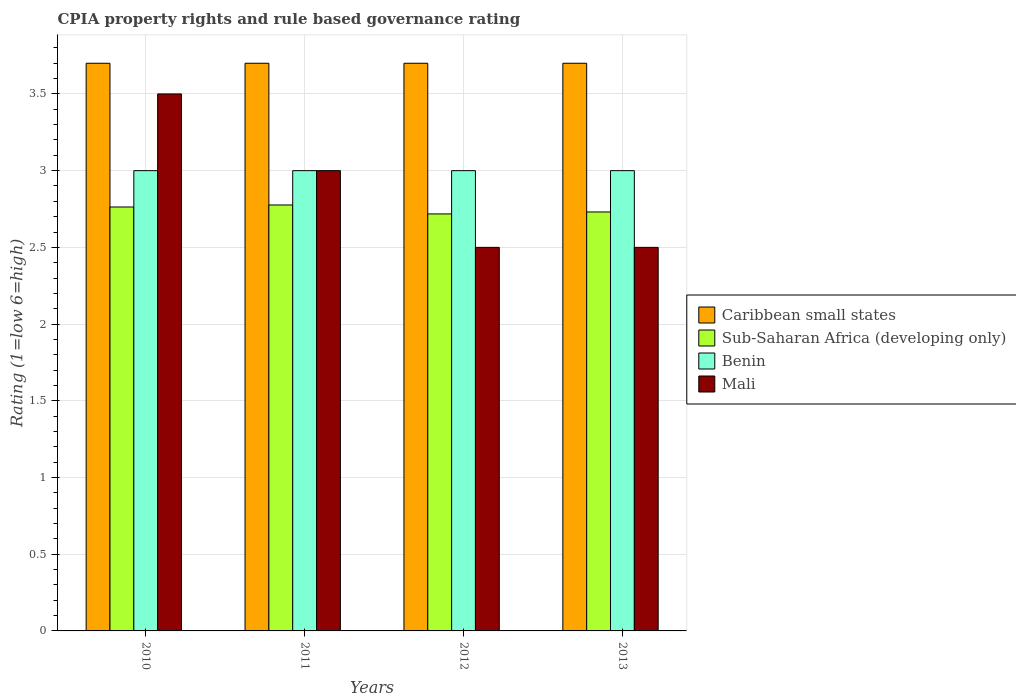How many different coloured bars are there?
Your response must be concise. 4. How many groups of bars are there?
Ensure brevity in your answer.  4. Are the number of bars per tick equal to the number of legend labels?
Your response must be concise. Yes. Are the number of bars on each tick of the X-axis equal?
Your answer should be very brief. Yes. What is the label of the 2nd group of bars from the left?
Make the answer very short. 2011. In how many cases, is the number of bars for a given year not equal to the number of legend labels?
Keep it short and to the point. 0. What is the CPIA rating in Sub-Saharan Africa (developing only) in 2012?
Provide a short and direct response. 2.72. Across all years, what is the maximum CPIA rating in Mali?
Offer a very short reply. 3.5. In which year was the CPIA rating in Mali maximum?
Offer a very short reply. 2010. In which year was the CPIA rating in Mali minimum?
Ensure brevity in your answer.  2012. What is the total CPIA rating in Mali in the graph?
Provide a succinct answer. 11.5. What is the difference between the CPIA rating in Caribbean small states in 2012 and the CPIA rating in Mali in 2013?
Your answer should be very brief. 1.2. In the year 2010, what is the difference between the CPIA rating in Mali and CPIA rating in Sub-Saharan Africa (developing only)?
Provide a short and direct response. 0.74. In how many years, is the CPIA rating in Caribbean small states greater than 2.4?
Provide a succinct answer. 4. Is the difference between the CPIA rating in Mali in 2012 and 2013 greater than the difference between the CPIA rating in Sub-Saharan Africa (developing only) in 2012 and 2013?
Your answer should be compact. Yes. What is the difference between the highest and the second highest CPIA rating in Caribbean small states?
Your answer should be compact. 0. In how many years, is the CPIA rating in Benin greater than the average CPIA rating in Benin taken over all years?
Provide a short and direct response. 0. Is the sum of the CPIA rating in Sub-Saharan Africa (developing only) in 2011 and 2013 greater than the maximum CPIA rating in Mali across all years?
Give a very brief answer. Yes. Is it the case that in every year, the sum of the CPIA rating in Benin and CPIA rating in Caribbean small states is greater than the sum of CPIA rating in Mali and CPIA rating in Sub-Saharan Africa (developing only)?
Your answer should be compact. Yes. What does the 4th bar from the left in 2010 represents?
Your answer should be compact. Mali. What does the 1st bar from the right in 2010 represents?
Your answer should be compact. Mali. Is it the case that in every year, the sum of the CPIA rating in Benin and CPIA rating in Sub-Saharan Africa (developing only) is greater than the CPIA rating in Caribbean small states?
Offer a very short reply. Yes. How many bars are there?
Your answer should be very brief. 16. Does the graph contain any zero values?
Your answer should be very brief. No. Does the graph contain grids?
Make the answer very short. Yes. What is the title of the graph?
Offer a very short reply. CPIA property rights and rule based governance rating. Does "Other small states" appear as one of the legend labels in the graph?
Offer a terse response. No. What is the label or title of the X-axis?
Ensure brevity in your answer.  Years. What is the Rating (1=low 6=high) of Sub-Saharan Africa (developing only) in 2010?
Offer a terse response. 2.76. What is the Rating (1=low 6=high) of Benin in 2010?
Provide a short and direct response. 3. What is the Rating (1=low 6=high) in Caribbean small states in 2011?
Keep it short and to the point. 3.7. What is the Rating (1=low 6=high) of Sub-Saharan Africa (developing only) in 2011?
Provide a succinct answer. 2.78. What is the Rating (1=low 6=high) of Benin in 2011?
Your answer should be very brief. 3. What is the Rating (1=low 6=high) of Sub-Saharan Africa (developing only) in 2012?
Provide a succinct answer. 2.72. What is the Rating (1=low 6=high) in Benin in 2012?
Provide a succinct answer. 3. What is the Rating (1=low 6=high) in Caribbean small states in 2013?
Give a very brief answer. 3.7. What is the Rating (1=low 6=high) of Sub-Saharan Africa (developing only) in 2013?
Give a very brief answer. 2.73. What is the Rating (1=low 6=high) in Mali in 2013?
Provide a short and direct response. 2.5. Across all years, what is the maximum Rating (1=low 6=high) in Sub-Saharan Africa (developing only)?
Your answer should be very brief. 2.78. Across all years, what is the maximum Rating (1=low 6=high) in Mali?
Give a very brief answer. 3.5. Across all years, what is the minimum Rating (1=low 6=high) of Caribbean small states?
Provide a succinct answer. 3.7. Across all years, what is the minimum Rating (1=low 6=high) in Sub-Saharan Africa (developing only)?
Offer a very short reply. 2.72. What is the total Rating (1=low 6=high) of Caribbean small states in the graph?
Your answer should be compact. 14.8. What is the total Rating (1=low 6=high) in Sub-Saharan Africa (developing only) in the graph?
Provide a short and direct response. 10.99. What is the total Rating (1=low 6=high) of Benin in the graph?
Make the answer very short. 12. What is the total Rating (1=low 6=high) in Mali in the graph?
Keep it short and to the point. 11.5. What is the difference between the Rating (1=low 6=high) of Sub-Saharan Africa (developing only) in 2010 and that in 2011?
Provide a succinct answer. -0.01. What is the difference between the Rating (1=low 6=high) of Benin in 2010 and that in 2011?
Your response must be concise. 0. What is the difference between the Rating (1=low 6=high) of Caribbean small states in 2010 and that in 2012?
Offer a very short reply. 0. What is the difference between the Rating (1=low 6=high) of Sub-Saharan Africa (developing only) in 2010 and that in 2012?
Your answer should be compact. 0.05. What is the difference between the Rating (1=low 6=high) in Benin in 2010 and that in 2012?
Provide a succinct answer. 0. What is the difference between the Rating (1=low 6=high) in Mali in 2010 and that in 2012?
Provide a short and direct response. 1. What is the difference between the Rating (1=low 6=high) in Sub-Saharan Africa (developing only) in 2010 and that in 2013?
Your answer should be very brief. 0.03. What is the difference between the Rating (1=low 6=high) of Mali in 2010 and that in 2013?
Keep it short and to the point. 1. What is the difference between the Rating (1=low 6=high) of Sub-Saharan Africa (developing only) in 2011 and that in 2012?
Make the answer very short. 0.06. What is the difference between the Rating (1=low 6=high) in Benin in 2011 and that in 2012?
Your answer should be compact. 0. What is the difference between the Rating (1=low 6=high) in Mali in 2011 and that in 2012?
Ensure brevity in your answer.  0.5. What is the difference between the Rating (1=low 6=high) in Sub-Saharan Africa (developing only) in 2011 and that in 2013?
Provide a short and direct response. 0.05. What is the difference between the Rating (1=low 6=high) of Mali in 2011 and that in 2013?
Ensure brevity in your answer.  0.5. What is the difference between the Rating (1=low 6=high) of Sub-Saharan Africa (developing only) in 2012 and that in 2013?
Your response must be concise. -0.01. What is the difference between the Rating (1=low 6=high) in Caribbean small states in 2010 and the Rating (1=low 6=high) in Sub-Saharan Africa (developing only) in 2011?
Offer a terse response. 0.92. What is the difference between the Rating (1=low 6=high) in Caribbean small states in 2010 and the Rating (1=low 6=high) in Mali in 2011?
Provide a short and direct response. 0.7. What is the difference between the Rating (1=low 6=high) in Sub-Saharan Africa (developing only) in 2010 and the Rating (1=low 6=high) in Benin in 2011?
Keep it short and to the point. -0.24. What is the difference between the Rating (1=low 6=high) of Sub-Saharan Africa (developing only) in 2010 and the Rating (1=low 6=high) of Mali in 2011?
Offer a terse response. -0.24. What is the difference between the Rating (1=low 6=high) of Benin in 2010 and the Rating (1=low 6=high) of Mali in 2011?
Make the answer very short. 0. What is the difference between the Rating (1=low 6=high) in Caribbean small states in 2010 and the Rating (1=low 6=high) in Sub-Saharan Africa (developing only) in 2012?
Give a very brief answer. 0.98. What is the difference between the Rating (1=low 6=high) in Caribbean small states in 2010 and the Rating (1=low 6=high) in Benin in 2012?
Keep it short and to the point. 0.7. What is the difference between the Rating (1=low 6=high) in Caribbean small states in 2010 and the Rating (1=low 6=high) in Mali in 2012?
Provide a succinct answer. 1.2. What is the difference between the Rating (1=low 6=high) in Sub-Saharan Africa (developing only) in 2010 and the Rating (1=low 6=high) in Benin in 2012?
Provide a short and direct response. -0.24. What is the difference between the Rating (1=low 6=high) of Sub-Saharan Africa (developing only) in 2010 and the Rating (1=low 6=high) of Mali in 2012?
Make the answer very short. 0.26. What is the difference between the Rating (1=low 6=high) in Caribbean small states in 2010 and the Rating (1=low 6=high) in Sub-Saharan Africa (developing only) in 2013?
Make the answer very short. 0.97. What is the difference between the Rating (1=low 6=high) of Caribbean small states in 2010 and the Rating (1=low 6=high) of Benin in 2013?
Keep it short and to the point. 0.7. What is the difference between the Rating (1=low 6=high) of Sub-Saharan Africa (developing only) in 2010 and the Rating (1=low 6=high) of Benin in 2013?
Provide a succinct answer. -0.24. What is the difference between the Rating (1=low 6=high) of Sub-Saharan Africa (developing only) in 2010 and the Rating (1=low 6=high) of Mali in 2013?
Your answer should be very brief. 0.26. What is the difference between the Rating (1=low 6=high) of Benin in 2010 and the Rating (1=low 6=high) of Mali in 2013?
Give a very brief answer. 0.5. What is the difference between the Rating (1=low 6=high) in Caribbean small states in 2011 and the Rating (1=low 6=high) in Sub-Saharan Africa (developing only) in 2012?
Ensure brevity in your answer.  0.98. What is the difference between the Rating (1=low 6=high) of Caribbean small states in 2011 and the Rating (1=low 6=high) of Benin in 2012?
Provide a short and direct response. 0.7. What is the difference between the Rating (1=low 6=high) of Caribbean small states in 2011 and the Rating (1=low 6=high) of Mali in 2012?
Your answer should be compact. 1.2. What is the difference between the Rating (1=low 6=high) in Sub-Saharan Africa (developing only) in 2011 and the Rating (1=low 6=high) in Benin in 2012?
Give a very brief answer. -0.22. What is the difference between the Rating (1=low 6=high) of Sub-Saharan Africa (developing only) in 2011 and the Rating (1=low 6=high) of Mali in 2012?
Give a very brief answer. 0.28. What is the difference between the Rating (1=low 6=high) in Caribbean small states in 2011 and the Rating (1=low 6=high) in Sub-Saharan Africa (developing only) in 2013?
Keep it short and to the point. 0.97. What is the difference between the Rating (1=low 6=high) in Sub-Saharan Africa (developing only) in 2011 and the Rating (1=low 6=high) in Benin in 2013?
Keep it short and to the point. -0.22. What is the difference between the Rating (1=low 6=high) of Sub-Saharan Africa (developing only) in 2011 and the Rating (1=low 6=high) of Mali in 2013?
Provide a succinct answer. 0.28. What is the difference between the Rating (1=low 6=high) of Caribbean small states in 2012 and the Rating (1=low 6=high) of Sub-Saharan Africa (developing only) in 2013?
Your answer should be compact. 0.97. What is the difference between the Rating (1=low 6=high) of Sub-Saharan Africa (developing only) in 2012 and the Rating (1=low 6=high) of Benin in 2013?
Provide a short and direct response. -0.28. What is the difference between the Rating (1=low 6=high) in Sub-Saharan Africa (developing only) in 2012 and the Rating (1=low 6=high) in Mali in 2013?
Provide a short and direct response. 0.22. What is the difference between the Rating (1=low 6=high) of Benin in 2012 and the Rating (1=low 6=high) of Mali in 2013?
Make the answer very short. 0.5. What is the average Rating (1=low 6=high) in Caribbean small states per year?
Provide a succinct answer. 3.7. What is the average Rating (1=low 6=high) of Sub-Saharan Africa (developing only) per year?
Make the answer very short. 2.75. What is the average Rating (1=low 6=high) in Benin per year?
Your response must be concise. 3. What is the average Rating (1=low 6=high) of Mali per year?
Give a very brief answer. 2.88. In the year 2010, what is the difference between the Rating (1=low 6=high) of Caribbean small states and Rating (1=low 6=high) of Sub-Saharan Africa (developing only)?
Ensure brevity in your answer.  0.94. In the year 2010, what is the difference between the Rating (1=low 6=high) in Caribbean small states and Rating (1=low 6=high) in Benin?
Offer a terse response. 0.7. In the year 2010, what is the difference between the Rating (1=low 6=high) in Sub-Saharan Africa (developing only) and Rating (1=low 6=high) in Benin?
Ensure brevity in your answer.  -0.24. In the year 2010, what is the difference between the Rating (1=low 6=high) of Sub-Saharan Africa (developing only) and Rating (1=low 6=high) of Mali?
Offer a terse response. -0.74. In the year 2011, what is the difference between the Rating (1=low 6=high) in Caribbean small states and Rating (1=low 6=high) in Sub-Saharan Africa (developing only)?
Your answer should be very brief. 0.92. In the year 2011, what is the difference between the Rating (1=low 6=high) in Caribbean small states and Rating (1=low 6=high) in Mali?
Provide a succinct answer. 0.7. In the year 2011, what is the difference between the Rating (1=low 6=high) of Sub-Saharan Africa (developing only) and Rating (1=low 6=high) of Benin?
Your response must be concise. -0.22. In the year 2011, what is the difference between the Rating (1=low 6=high) in Sub-Saharan Africa (developing only) and Rating (1=low 6=high) in Mali?
Offer a very short reply. -0.22. In the year 2012, what is the difference between the Rating (1=low 6=high) in Caribbean small states and Rating (1=low 6=high) in Sub-Saharan Africa (developing only)?
Offer a very short reply. 0.98. In the year 2012, what is the difference between the Rating (1=low 6=high) of Sub-Saharan Africa (developing only) and Rating (1=low 6=high) of Benin?
Your answer should be very brief. -0.28. In the year 2012, what is the difference between the Rating (1=low 6=high) of Sub-Saharan Africa (developing only) and Rating (1=low 6=high) of Mali?
Your answer should be compact. 0.22. In the year 2012, what is the difference between the Rating (1=low 6=high) in Benin and Rating (1=low 6=high) in Mali?
Give a very brief answer. 0.5. In the year 2013, what is the difference between the Rating (1=low 6=high) of Caribbean small states and Rating (1=low 6=high) of Sub-Saharan Africa (developing only)?
Your answer should be compact. 0.97. In the year 2013, what is the difference between the Rating (1=low 6=high) in Sub-Saharan Africa (developing only) and Rating (1=low 6=high) in Benin?
Your answer should be very brief. -0.27. In the year 2013, what is the difference between the Rating (1=low 6=high) in Sub-Saharan Africa (developing only) and Rating (1=low 6=high) in Mali?
Offer a terse response. 0.23. In the year 2013, what is the difference between the Rating (1=low 6=high) of Benin and Rating (1=low 6=high) of Mali?
Provide a short and direct response. 0.5. What is the ratio of the Rating (1=low 6=high) in Caribbean small states in 2010 to that in 2011?
Keep it short and to the point. 1. What is the ratio of the Rating (1=low 6=high) of Caribbean small states in 2010 to that in 2012?
Ensure brevity in your answer.  1. What is the ratio of the Rating (1=low 6=high) of Sub-Saharan Africa (developing only) in 2010 to that in 2012?
Your answer should be very brief. 1.02. What is the ratio of the Rating (1=low 6=high) in Benin in 2010 to that in 2012?
Provide a succinct answer. 1. What is the ratio of the Rating (1=low 6=high) in Mali in 2010 to that in 2012?
Ensure brevity in your answer.  1.4. What is the ratio of the Rating (1=low 6=high) of Sub-Saharan Africa (developing only) in 2010 to that in 2013?
Offer a very short reply. 1.01. What is the ratio of the Rating (1=low 6=high) in Caribbean small states in 2011 to that in 2012?
Provide a short and direct response. 1. What is the ratio of the Rating (1=low 6=high) of Sub-Saharan Africa (developing only) in 2011 to that in 2012?
Provide a succinct answer. 1.02. What is the ratio of the Rating (1=low 6=high) in Sub-Saharan Africa (developing only) in 2011 to that in 2013?
Your answer should be compact. 1.02. What is the difference between the highest and the second highest Rating (1=low 6=high) of Sub-Saharan Africa (developing only)?
Your response must be concise. 0.01. What is the difference between the highest and the second highest Rating (1=low 6=high) in Benin?
Your response must be concise. 0. What is the difference between the highest and the second highest Rating (1=low 6=high) in Mali?
Provide a short and direct response. 0.5. What is the difference between the highest and the lowest Rating (1=low 6=high) of Sub-Saharan Africa (developing only)?
Ensure brevity in your answer.  0.06. 